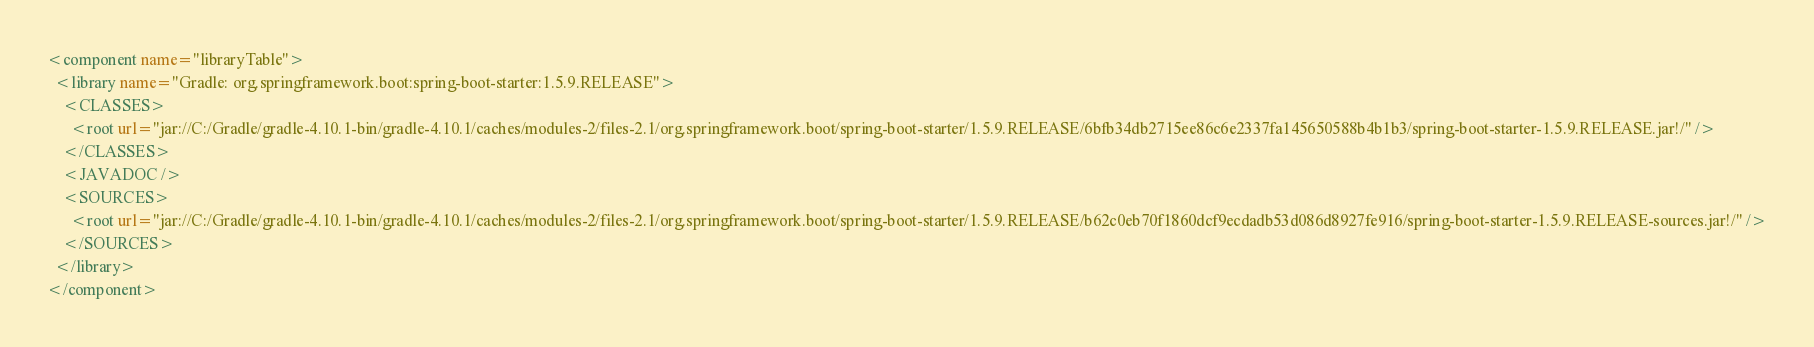<code> <loc_0><loc_0><loc_500><loc_500><_XML_><component name="libraryTable">
  <library name="Gradle: org.springframework.boot:spring-boot-starter:1.5.9.RELEASE">
    <CLASSES>
      <root url="jar://C:/Gradle/gradle-4.10.1-bin/gradle-4.10.1/caches/modules-2/files-2.1/org.springframework.boot/spring-boot-starter/1.5.9.RELEASE/6bfb34db2715ee86c6e2337fa145650588b4b1b3/spring-boot-starter-1.5.9.RELEASE.jar!/" />
    </CLASSES>
    <JAVADOC />
    <SOURCES>
      <root url="jar://C:/Gradle/gradle-4.10.1-bin/gradle-4.10.1/caches/modules-2/files-2.1/org.springframework.boot/spring-boot-starter/1.5.9.RELEASE/b62c0eb70f1860dcf9ecdadb53d086d8927fe916/spring-boot-starter-1.5.9.RELEASE-sources.jar!/" />
    </SOURCES>
  </library>
</component></code> 